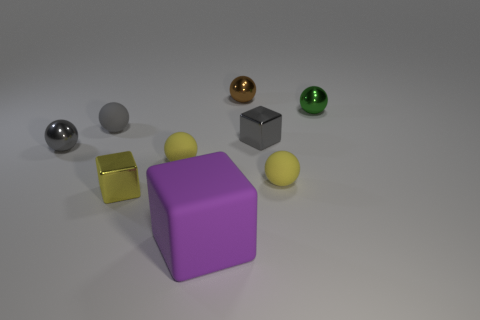What is the size of the yellow rubber object that is on the right side of the object behind the green metallic sphere?
Your response must be concise. Small. What color is the tiny metal ball that is to the left of the green metal object and right of the yellow metallic cube?
Keep it short and to the point. Brown. Do the tiny yellow metal thing and the small gray rubber object have the same shape?
Your answer should be very brief. No. Are there an equal number of green metal balls and cubes?
Your response must be concise. No. What is the shape of the large purple matte object that is to the right of the rubber sphere that is on the left side of the yellow cube?
Provide a succinct answer. Cube. Is the shape of the gray matte object the same as the shiny thing behind the green metal ball?
Provide a succinct answer. Yes. What is the color of the block that is the same size as the yellow metal object?
Your answer should be very brief. Gray. Is the number of tiny gray objects that are in front of the gray cube less than the number of gray objects that are in front of the gray metallic ball?
Offer a terse response. No. There is a object that is behind the green sphere that is behind the cube to the left of the purple object; what is its shape?
Provide a succinct answer. Sphere. There is a small object that is behind the green ball; does it have the same color as the small shiny sphere left of the small brown metallic ball?
Your response must be concise. No. 